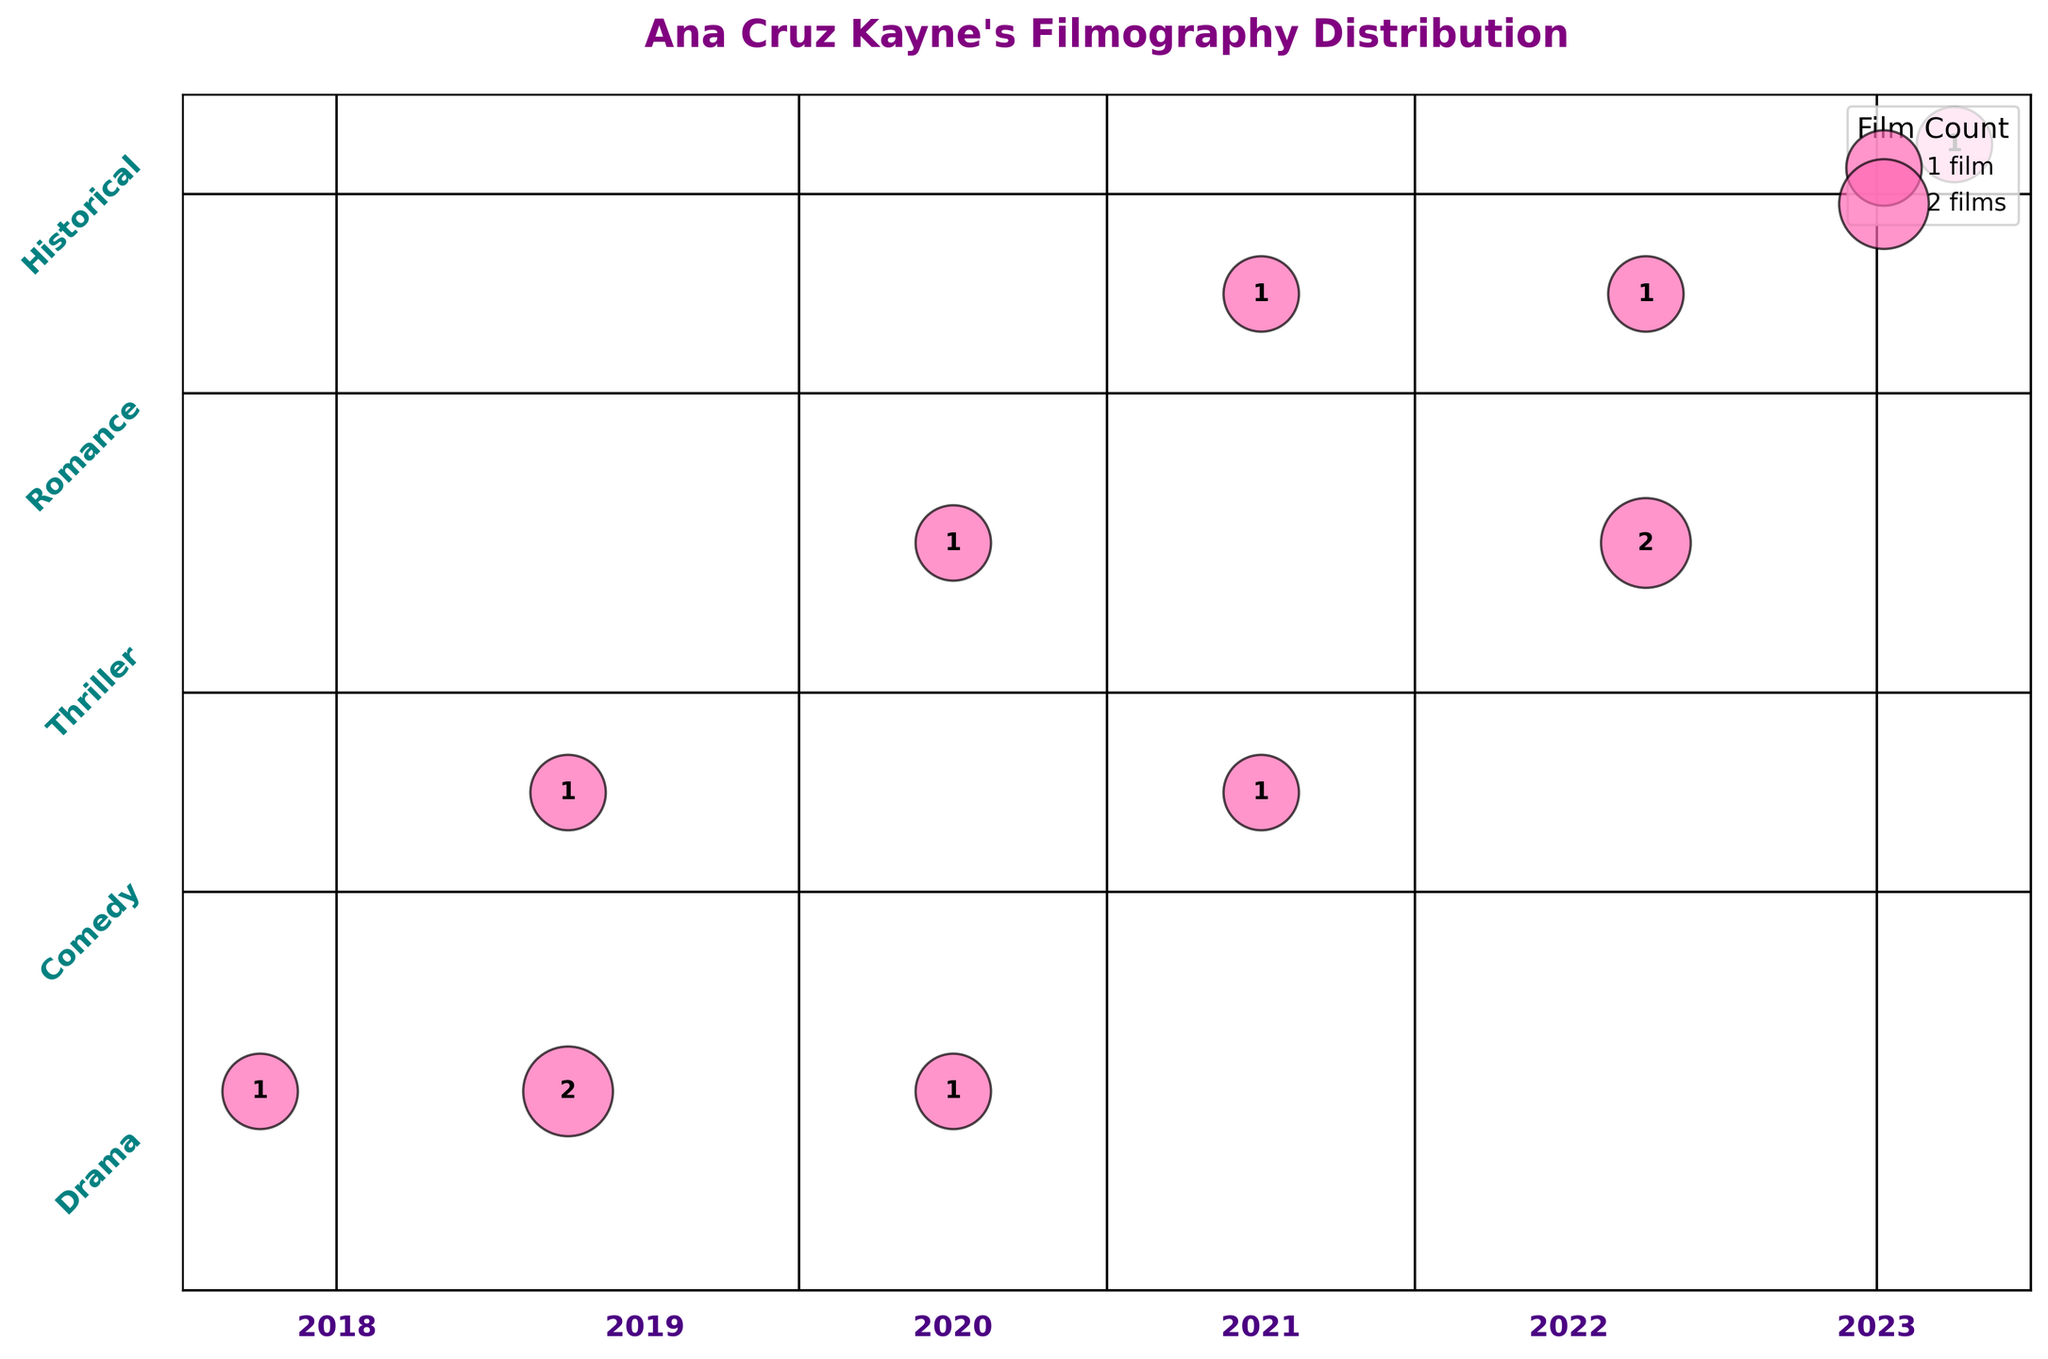What's the title of the plot? The title of the plot is usually written at the top of the figure, in this case, it is "Ana Cruz Kayne's Filmography Distribution".
Answer: Ana Cruz Kayne's Filmography Distribution Which genre has the highest film count in 2022? Look at the intersection of the "Thriller" genre and the year 2022. It has 2 films, which is the highest compared to other genres in 2022.
Answer: Thriller How many genres did Ana Cruz Kayne work in during 2019? Identify all unique genres listed along the y-axis for the year 2019. They are "Drama" and "Comedy".
Answer: 2 Which genre has the fewest total films across all years? Compare the total counts of films in each genre by summing the values across all years for each genre. "Historical" and "Romance" both have the fewest with a total of 1 each.
Answer: Historical / Romance How many years are covered in Ana Cruz Kayne's filmography according to this plot? Look at the entire range of years covered along the x-axis. It spans from 2018 to 2023.
Answer: 6 Which year saw the highest number of Drama films released? Check the film counts for "Drama" across different years. The highest count is in 2019, with 2 films.
Answer: 2019 What proportion of Ana Cruz Kayne's filmography in 2020 is made up of Thriller films? In 2020, identify the counts for all genres. Thriller has 1 film and the total in 2020 is 2 (1 Drama + 1 Thriller). Therefore, the proportion is 1/2.
Answer: 50% How does the number of Comedy films in 2019 compare to that in 2021? Locate the counts for "Comedy" in 2019 and 2021. In 2019, there is 1 film, and in 2021, there is also 1 film. They are equal.
Answer: Equal What is the total number of films listed in the Mosaic Plot? Sum all the counts listed in each cell of the plot. The total is 1+2+1+1+1+1+2+1+1+1=12.
Answer: 12 Are there any genres that do not appear in any year? Check the plot to see if there are any genres listed on the y-axis without any corresponding values in the plot. All genres listed have at least one value, so none are missing.
Answer: No 